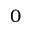<formula> <loc_0><loc_0><loc_500><loc_500>0</formula> 